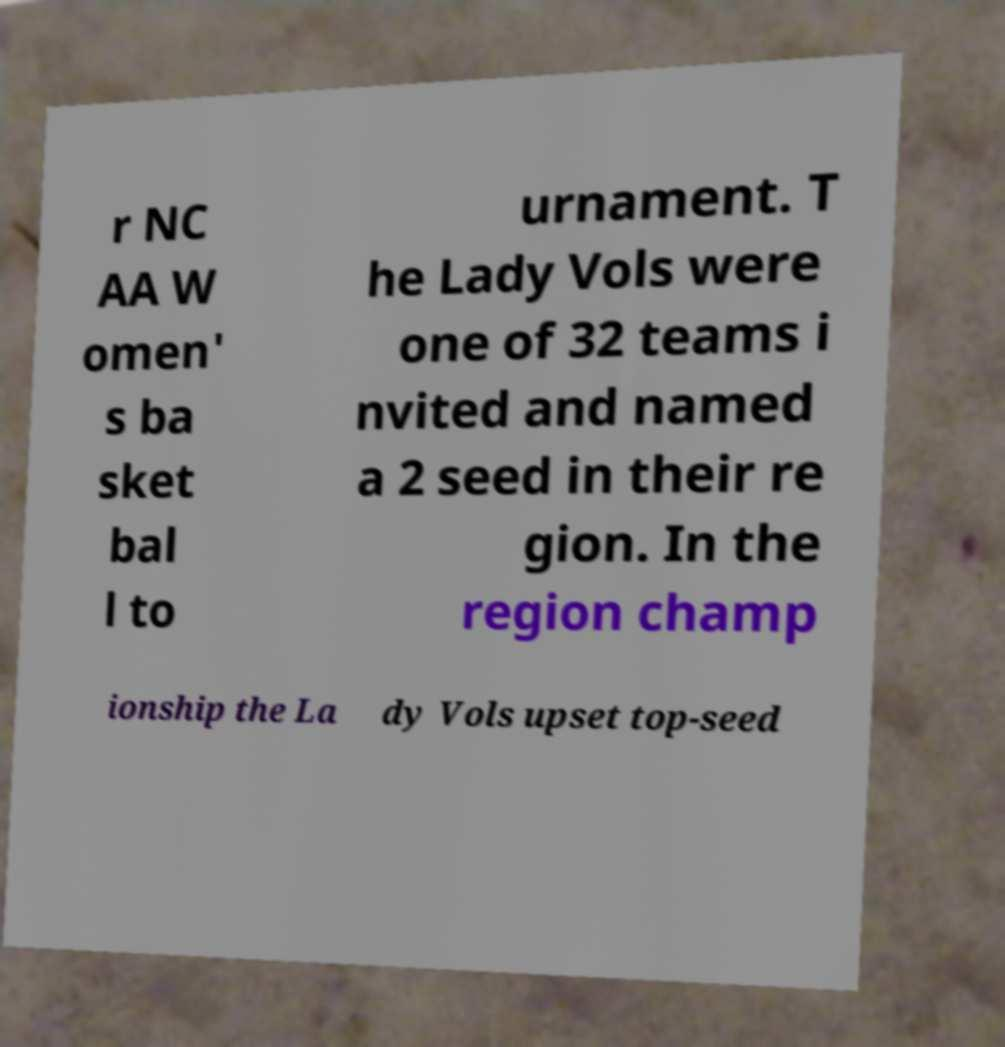Could you extract and type out the text from this image? r NC AA W omen' s ba sket bal l to urnament. T he Lady Vols were one of 32 teams i nvited and named a 2 seed in their re gion. In the region champ ionship the La dy Vols upset top-seed 